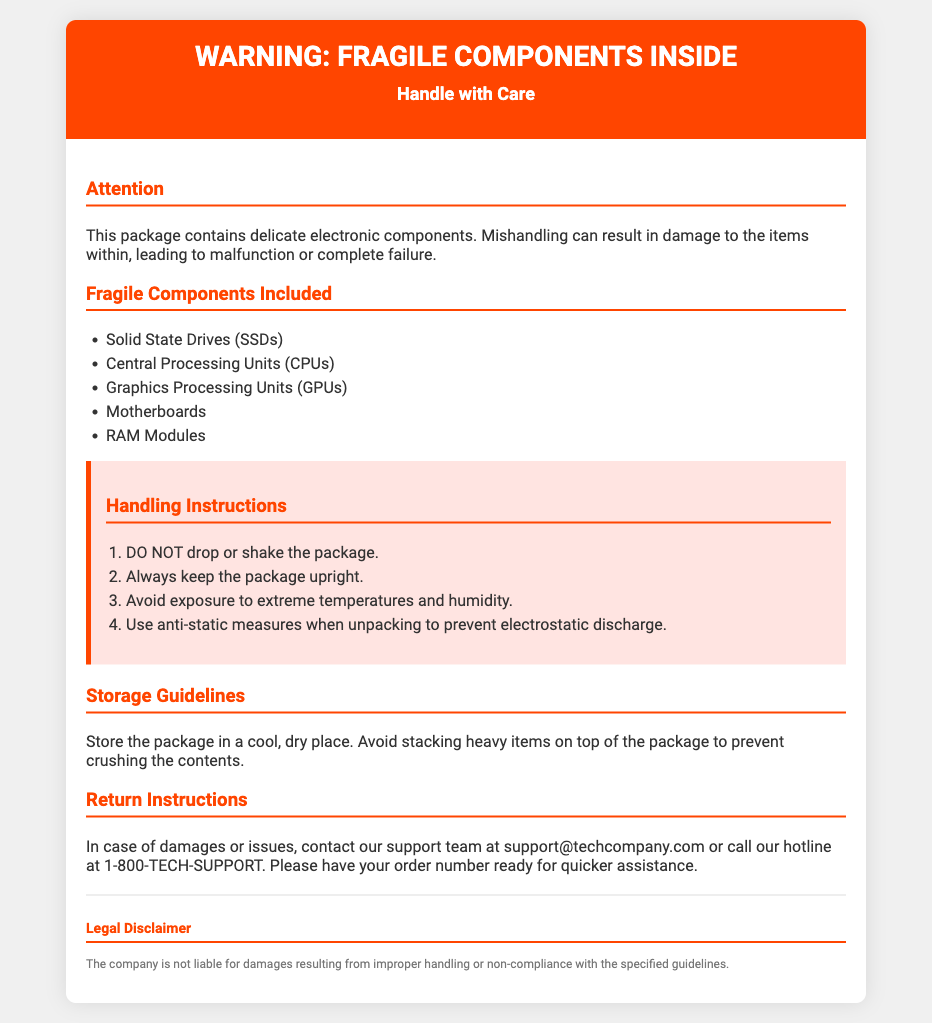What is the title of the document? The title of the document is presented prominently at the top of the page.
Answer: Warning: Fragile Components Inside How many types of fragile components are listed? The document lists five types of fragile components under a specific section.
Answer: Five What should you avoid doing with the package? The handling instructions specify actions to avoid when handling the package.
Answer: Drop or shake the package What is the support email provided for assistance? The document provides contact information for support in the Return Instructions section.
Answer: support@techcompany.com What type of items should not be stacked on the package? The storage guidelines specify a caution regarding heavy items.
Answer: Heavy items What exposure should be avoided when handling the package? The handling instructions mention specific environmental conditions to avoid.
Answer: Extreme temperatures and humidity What does the legal disclaimer state regarding liability? The legal disclaimer outlines the company's position on handling compliance.
Answer: Not liable for damages Which component is NOT mentioned in the fragile components list? The question checks knowledge of components not included in the list.
Answer: Hard drives 